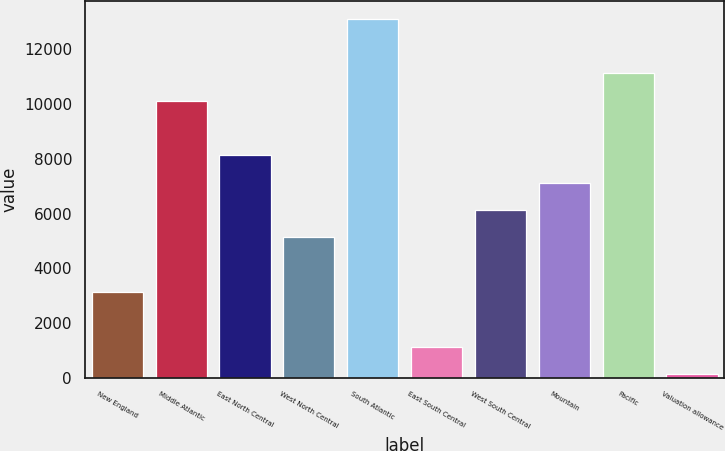Convert chart to OTSL. <chart><loc_0><loc_0><loc_500><loc_500><bar_chart><fcel>New England<fcel>Middle Atlantic<fcel>East North Central<fcel>West North Central<fcel>South Atlantic<fcel>East South Central<fcel>West South Central<fcel>Mountain<fcel>Pacific<fcel>Valuation allowance<nl><fcel>3129.29<fcel>10121.8<fcel>8123.94<fcel>5127.15<fcel>13118.6<fcel>1131.43<fcel>6126.08<fcel>7125.01<fcel>11120.7<fcel>132.5<nl></chart> 